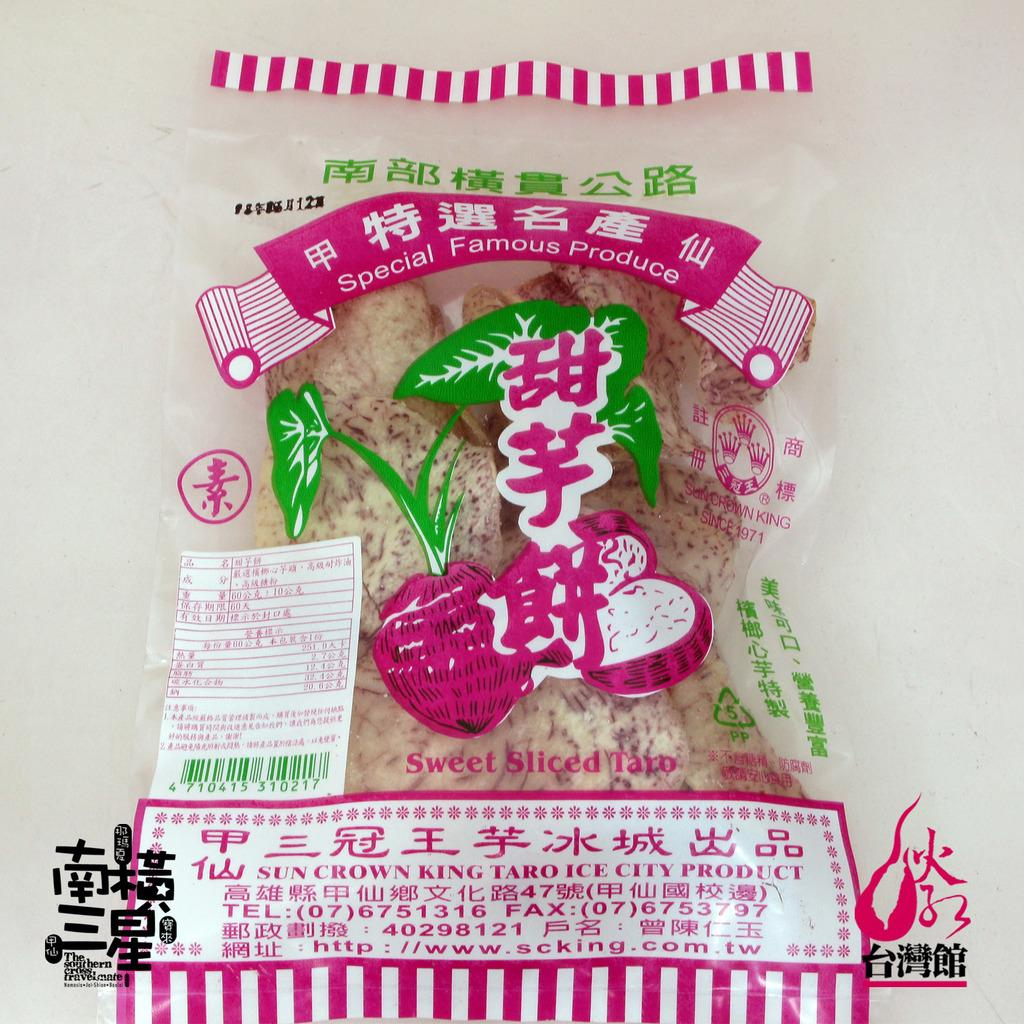<image>
Offer a succinct explanation of the picture presented. A bag with pink and green images on it contains sweet sliced taro. 